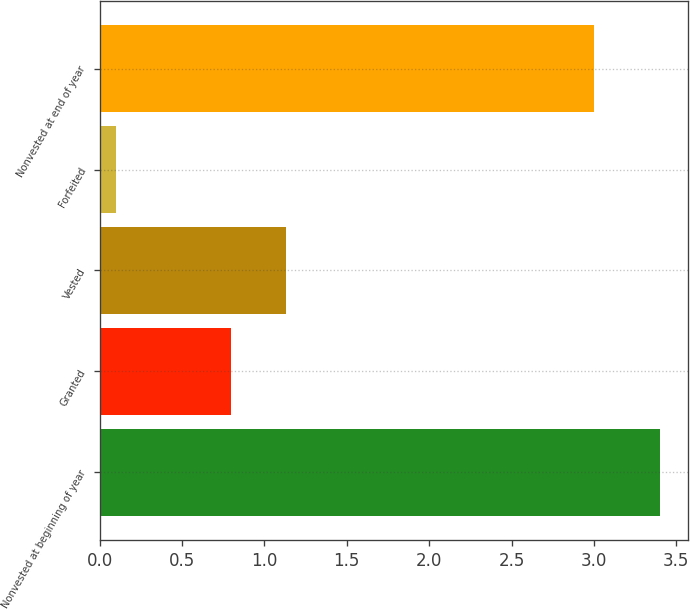<chart> <loc_0><loc_0><loc_500><loc_500><bar_chart><fcel>Nonvested at beginning of year<fcel>Granted<fcel>Vested<fcel>Forfeited<fcel>Nonvested at end of year<nl><fcel>3.4<fcel>0.8<fcel>1.13<fcel>0.1<fcel>3<nl></chart> 